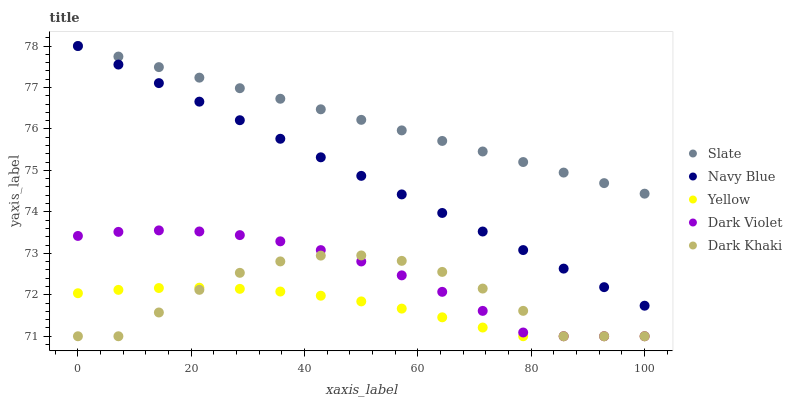Does Yellow have the minimum area under the curve?
Answer yes or no. Yes. Does Slate have the maximum area under the curve?
Answer yes or no. Yes. Does Navy Blue have the minimum area under the curve?
Answer yes or no. No. Does Navy Blue have the maximum area under the curve?
Answer yes or no. No. Is Slate the smoothest?
Answer yes or no. Yes. Is Dark Khaki the roughest?
Answer yes or no. Yes. Is Navy Blue the smoothest?
Answer yes or no. No. Is Navy Blue the roughest?
Answer yes or no. No. Does Dark Khaki have the lowest value?
Answer yes or no. Yes. Does Navy Blue have the lowest value?
Answer yes or no. No. Does Slate have the highest value?
Answer yes or no. Yes. Does Dark Violet have the highest value?
Answer yes or no. No. Is Dark Khaki less than Navy Blue?
Answer yes or no. Yes. Is Navy Blue greater than Dark Violet?
Answer yes or no. Yes. Does Yellow intersect Dark Khaki?
Answer yes or no. Yes. Is Yellow less than Dark Khaki?
Answer yes or no. No. Is Yellow greater than Dark Khaki?
Answer yes or no. No. Does Dark Khaki intersect Navy Blue?
Answer yes or no. No. 